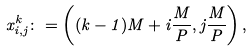<formula> <loc_0><loc_0><loc_500><loc_500>x _ { i , j } ^ { k } \colon = \left ( ( k - 1 ) M + i \frac { M } { P } , j \frac { M } { P } \right ) ,</formula> 